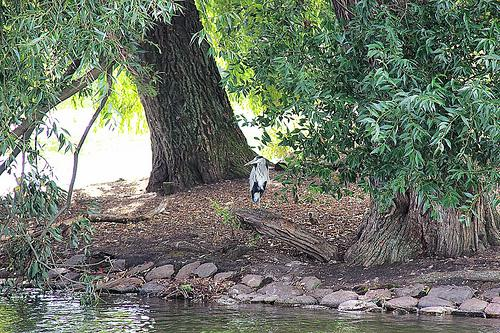Question: where are the rocks?
Choices:
A. On the road.
B. Bottom, left.
C. To the right.
D. Next to the elephant.
Answer with the letter. Answer: B Question: what is on the right?
Choices:
A. Bridge.
B. Tunnel.
C. Tree.
D. Giraffe.
Answer with the letter. Answer: C Question: what color are the tree leaves?
Choices:
A. Green.
B. Brown.
C. Yellow.
D. Black.
Answer with the letter. Answer: A Question: where was the photo taken?
Choices:
A. The beach.
B. A farm.
C. On river.
D. The bar.
Answer with the letter. Answer: C 